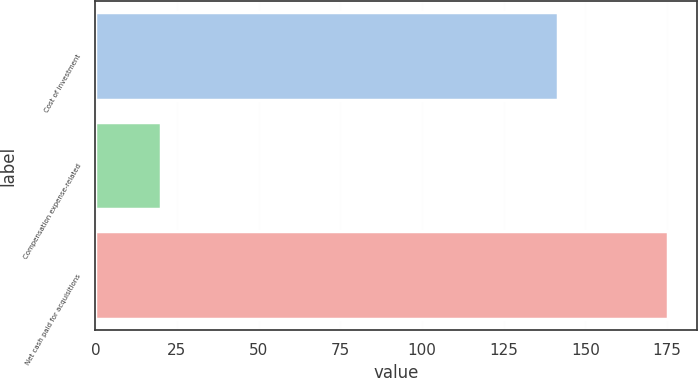<chart> <loc_0><loc_0><loc_500><loc_500><bar_chart><fcel>Cost of investment<fcel>Compensation expense-related<fcel>Net cash paid for acquisitions<nl><fcel>141.6<fcel>20.1<fcel>175.4<nl></chart> 